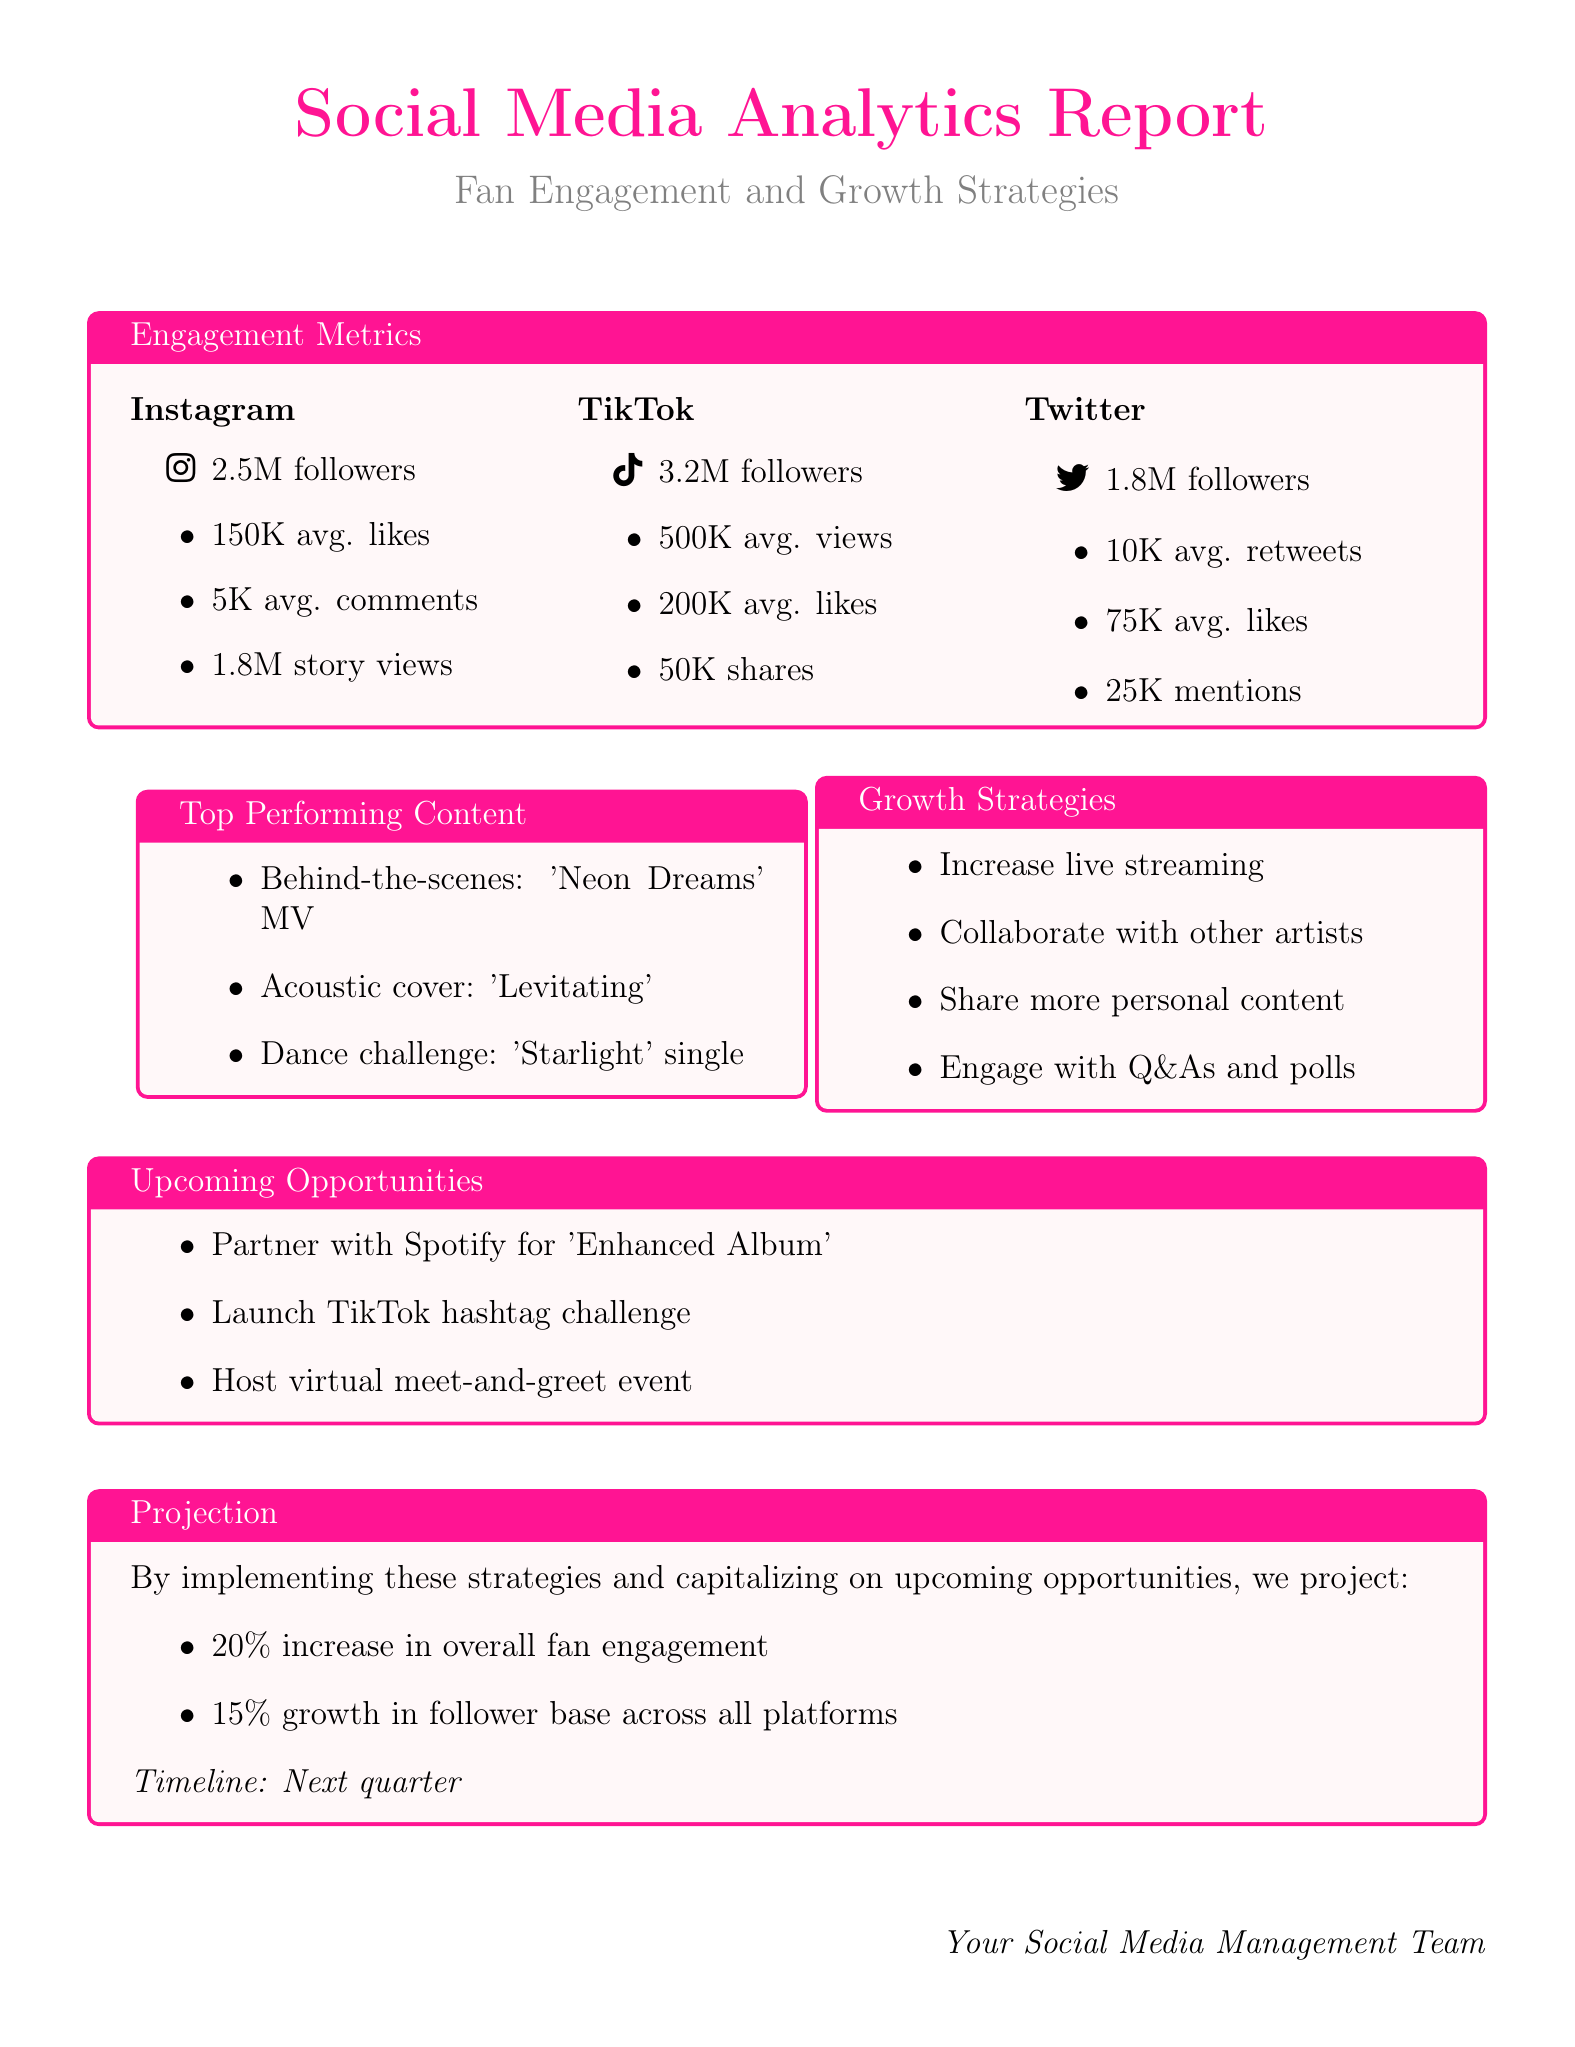What are the average likes on Instagram? The average likes on Instagram are specified in the document, which states "150K avg. likes."
Answer: 150K avg. likes How many followers do you have on TikTok? The number of followers on TikTok is given in the metrics; it states "3.2M followers."
Answer: 3.2M followers What is one of the top-performing pieces of content? One top-performing content mentioned is "Behind-the-scenes footage from your 'Neon Dreams' music video."
Answer: Behind-the-scenes footage from your 'Neon Dreams' music video What is a suggested growth strategy? The document lists several strategies; one is "Increase live streaming sessions on Instagram and TikTok."
Answer: Increase live streaming sessions on Instagram and TikTok What percentage increase in fan engagement is projected? The document states a projection for fan engagement increase of "20%."
Answer: 20% What platform has the highest average views? The average views are provided for TikTok, which states "500K avg. views," showing it has the highest views.
Answer: 500K avg. views What are the average comments on Instagram? The document mentions "5K avg. comments" for Instagram, which provides the necessary metric.
Answer: 5K avg. comments What type of event is planned for top fans? The document lists "Host a virtual meet-and-greet event for top fans" as an upcoming opportunity.
Answer: Host a virtual meet-and-greet event What is the total average number of followers across all platforms? The total is derived from adding the followers: 2.5M (Instagram) + 3.2M (TikTok) + 1.8M (Twitter) = 7.5M followers.
Answer: 7.5M followers 